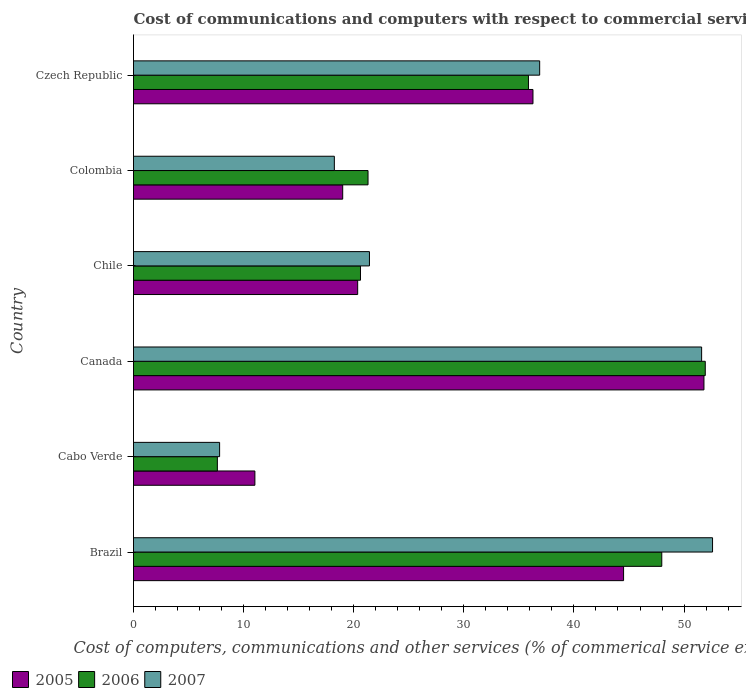Are the number of bars per tick equal to the number of legend labels?
Provide a short and direct response. Yes. Are the number of bars on each tick of the Y-axis equal?
Provide a short and direct response. Yes. How many bars are there on the 6th tick from the top?
Provide a short and direct response. 3. How many bars are there on the 5th tick from the bottom?
Keep it short and to the point. 3. What is the label of the 3rd group of bars from the top?
Offer a very short reply. Chile. In how many cases, is the number of bars for a given country not equal to the number of legend labels?
Offer a terse response. 0. What is the cost of communications and computers in 2005 in Colombia?
Your response must be concise. 19. Across all countries, what is the maximum cost of communications and computers in 2005?
Provide a short and direct response. 51.81. Across all countries, what is the minimum cost of communications and computers in 2005?
Provide a short and direct response. 11.02. In which country was the cost of communications and computers in 2005 minimum?
Your answer should be compact. Cabo Verde. What is the total cost of communications and computers in 2007 in the graph?
Provide a short and direct response. 188.56. What is the difference between the cost of communications and computers in 2006 in Canada and that in Chile?
Your answer should be compact. 31.31. What is the difference between the cost of communications and computers in 2006 in Canada and the cost of communications and computers in 2007 in Czech Republic?
Your response must be concise. 15.04. What is the average cost of communications and computers in 2006 per country?
Offer a terse response. 30.88. What is the difference between the cost of communications and computers in 2005 and cost of communications and computers in 2007 in Canada?
Offer a very short reply. 0.21. What is the ratio of the cost of communications and computers in 2005 in Brazil to that in Chile?
Your response must be concise. 2.19. Is the difference between the cost of communications and computers in 2005 in Canada and Colombia greater than the difference between the cost of communications and computers in 2007 in Canada and Colombia?
Offer a terse response. No. What is the difference between the highest and the second highest cost of communications and computers in 2007?
Give a very brief answer. 0.99. What is the difference between the highest and the lowest cost of communications and computers in 2006?
Offer a very short reply. 44.31. In how many countries, is the cost of communications and computers in 2005 greater than the average cost of communications and computers in 2005 taken over all countries?
Ensure brevity in your answer.  3. Is it the case that in every country, the sum of the cost of communications and computers in 2007 and cost of communications and computers in 2005 is greater than the cost of communications and computers in 2006?
Provide a short and direct response. Yes. How many bars are there?
Give a very brief answer. 18. How many countries are there in the graph?
Your response must be concise. 6. Are the values on the major ticks of X-axis written in scientific E-notation?
Ensure brevity in your answer.  No. Does the graph contain any zero values?
Give a very brief answer. No. Does the graph contain grids?
Provide a short and direct response. No. What is the title of the graph?
Your response must be concise. Cost of communications and computers with respect to commercial service exports. Does "1975" appear as one of the legend labels in the graph?
Provide a short and direct response. No. What is the label or title of the X-axis?
Give a very brief answer. Cost of computers, communications and other services (% of commerical service exports). What is the Cost of computers, communications and other services (% of commerical service exports) in 2005 in Brazil?
Ensure brevity in your answer.  44.51. What is the Cost of computers, communications and other services (% of commerical service exports) of 2006 in Brazil?
Keep it short and to the point. 47.98. What is the Cost of computers, communications and other services (% of commerical service exports) in 2007 in Brazil?
Your response must be concise. 52.59. What is the Cost of computers, communications and other services (% of commerical service exports) of 2005 in Cabo Verde?
Ensure brevity in your answer.  11.02. What is the Cost of computers, communications and other services (% of commerical service exports) of 2006 in Cabo Verde?
Provide a succinct answer. 7.62. What is the Cost of computers, communications and other services (% of commerical service exports) of 2007 in Cabo Verde?
Offer a very short reply. 7.82. What is the Cost of computers, communications and other services (% of commerical service exports) in 2005 in Canada?
Provide a short and direct response. 51.81. What is the Cost of computers, communications and other services (% of commerical service exports) of 2006 in Canada?
Your answer should be compact. 51.93. What is the Cost of computers, communications and other services (% of commerical service exports) in 2007 in Canada?
Give a very brief answer. 51.6. What is the Cost of computers, communications and other services (% of commerical service exports) of 2005 in Chile?
Make the answer very short. 20.36. What is the Cost of computers, communications and other services (% of commerical service exports) of 2006 in Chile?
Your response must be concise. 20.61. What is the Cost of computers, communications and other services (% of commerical service exports) of 2007 in Chile?
Your response must be concise. 21.43. What is the Cost of computers, communications and other services (% of commerical service exports) of 2005 in Colombia?
Your answer should be compact. 19. What is the Cost of computers, communications and other services (% of commerical service exports) in 2006 in Colombia?
Offer a terse response. 21.3. What is the Cost of computers, communications and other services (% of commerical service exports) in 2007 in Colombia?
Offer a very short reply. 18.24. What is the Cost of computers, communications and other services (% of commerical service exports) in 2005 in Czech Republic?
Keep it short and to the point. 36.28. What is the Cost of computers, communications and other services (% of commerical service exports) in 2006 in Czech Republic?
Provide a succinct answer. 35.87. What is the Cost of computers, communications and other services (% of commerical service exports) in 2007 in Czech Republic?
Offer a very short reply. 36.89. Across all countries, what is the maximum Cost of computers, communications and other services (% of commerical service exports) in 2005?
Give a very brief answer. 51.81. Across all countries, what is the maximum Cost of computers, communications and other services (% of commerical service exports) of 2006?
Offer a terse response. 51.93. Across all countries, what is the maximum Cost of computers, communications and other services (% of commerical service exports) of 2007?
Give a very brief answer. 52.59. Across all countries, what is the minimum Cost of computers, communications and other services (% of commerical service exports) in 2005?
Provide a short and direct response. 11.02. Across all countries, what is the minimum Cost of computers, communications and other services (% of commerical service exports) in 2006?
Ensure brevity in your answer.  7.62. Across all countries, what is the minimum Cost of computers, communications and other services (% of commerical service exports) in 2007?
Your answer should be compact. 7.82. What is the total Cost of computers, communications and other services (% of commerical service exports) of 2005 in the graph?
Your answer should be compact. 182.97. What is the total Cost of computers, communications and other services (% of commerical service exports) in 2006 in the graph?
Your answer should be very brief. 185.3. What is the total Cost of computers, communications and other services (% of commerical service exports) in 2007 in the graph?
Offer a terse response. 188.56. What is the difference between the Cost of computers, communications and other services (% of commerical service exports) of 2005 in Brazil and that in Cabo Verde?
Your answer should be very brief. 33.48. What is the difference between the Cost of computers, communications and other services (% of commerical service exports) of 2006 in Brazil and that in Cabo Verde?
Your answer should be compact. 40.36. What is the difference between the Cost of computers, communications and other services (% of commerical service exports) in 2007 in Brazil and that in Cabo Verde?
Keep it short and to the point. 44.77. What is the difference between the Cost of computers, communications and other services (% of commerical service exports) in 2005 in Brazil and that in Canada?
Your answer should be compact. -7.3. What is the difference between the Cost of computers, communications and other services (% of commerical service exports) in 2006 in Brazil and that in Canada?
Ensure brevity in your answer.  -3.95. What is the difference between the Cost of computers, communications and other services (% of commerical service exports) of 2005 in Brazil and that in Chile?
Your answer should be very brief. 24.15. What is the difference between the Cost of computers, communications and other services (% of commerical service exports) in 2006 in Brazil and that in Chile?
Your response must be concise. 27.36. What is the difference between the Cost of computers, communications and other services (% of commerical service exports) of 2007 in Brazil and that in Chile?
Provide a short and direct response. 31.16. What is the difference between the Cost of computers, communications and other services (% of commerical service exports) of 2005 in Brazil and that in Colombia?
Your answer should be compact. 25.51. What is the difference between the Cost of computers, communications and other services (% of commerical service exports) in 2006 in Brazil and that in Colombia?
Provide a succinct answer. 26.68. What is the difference between the Cost of computers, communications and other services (% of commerical service exports) in 2007 in Brazil and that in Colombia?
Give a very brief answer. 34.35. What is the difference between the Cost of computers, communications and other services (% of commerical service exports) in 2005 in Brazil and that in Czech Republic?
Your response must be concise. 8.23. What is the difference between the Cost of computers, communications and other services (% of commerical service exports) in 2006 in Brazil and that in Czech Republic?
Ensure brevity in your answer.  12.11. What is the difference between the Cost of computers, communications and other services (% of commerical service exports) in 2007 in Brazil and that in Czech Republic?
Provide a succinct answer. 15.7. What is the difference between the Cost of computers, communications and other services (% of commerical service exports) in 2005 in Cabo Verde and that in Canada?
Your answer should be very brief. -40.78. What is the difference between the Cost of computers, communications and other services (% of commerical service exports) in 2006 in Cabo Verde and that in Canada?
Provide a succinct answer. -44.31. What is the difference between the Cost of computers, communications and other services (% of commerical service exports) of 2007 in Cabo Verde and that in Canada?
Offer a terse response. -43.78. What is the difference between the Cost of computers, communications and other services (% of commerical service exports) of 2005 in Cabo Verde and that in Chile?
Your answer should be compact. -9.33. What is the difference between the Cost of computers, communications and other services (% of commerical service exports) of 2006 in Cabo Verde and that in Chile?
Ensure brevity in your answer.  -13. What is the difference between the Cost of computers, communications and other services (% of commerical service exports) of 2007 in Cabo Verde and that in Chile?
Your response must be concise. -13.61. What is the difference between the Cost of computers, communications and other services (% of commerical service exports) in 2005 in Cabo Verde and that in Colombia?
Ensure brevity in your answer.  -7.97. What is the difference between the Cost of computers, communications and other services (% of commerical service exports) in 2006 in Cabo Verde and that in Colombia?
Your response must be concise. -13.68. What is the difference between the Cost of computers, communications and other services (% of commerical service exports) of 2007 in Cabo Verde and that in Colombia?
Provide a short and direct response. -10.42. What is the difference between the Cost of computers, communications and other services (% of commerical service exports) in 2005 in Cabo Verde and that in Czech Republic?
Provide a short and direct response. -25.25. What is the difference between the Cost of computers, communications and other services (% of commerical service exports) of 2006 in Cabo Verde and that in Czech Republic?
Offer a terse response. -28.25. What is the difference between the Cost of computers, communications and other services (% of commerical service exports) in 2007 in Cabo Verde and that in Czech Republic?
Offer a terse response. -29.07. What is the difference between the Cost of computers, communications and other services (% of commerical service exports) of 2005 in Canada and that in Chile?
Your answer should be very brief. 31.45. What is the difference between the Cost of computers, communications and other services (% of commerical service exports) of 2006 in Canada and that in Chile?
Offer a terse response. 31.31. What is the difference between the Cost of computers, communications and other services (% of commerical service exports) of 2007 in Canada and that in Chile?
Give a very brief answer. 30.17. What is the difference between the Cost of computers, communications and other services (% of commerical service exports) in 2005 in Canada and that in Colombia?
Your answer should be compact. 32.81. What is the difference between the Cost of computers, communications and other services (% of commerical service exports) of 2006 in Canada and that in Colombia?
Offer a very short reply. 30.63. What is the difference between the Cost of computers, communications and other services (% of commerical service exports) of 2007 in Canada and that in Colombia?
Ensure brevity in your answer.  33.36. What is the difference between the Cost of computers, communications and other services (% of commerical service exports) of 2005 in Canada and that in Czech Republic?
Make the answer very short. 15.53. What is the difference between the Cost of computers, communications and other services (% of commerical service exports) of 2006 in Canada and that in Czech Republic?
Provide a short and direct response. 16.06. What is the difference between the Cost of computers, communications and other services (% of commerical service exports) of 2007 in Canada and that in Czech Republic?
Your answer should be compact. 14.71. What is the difference between the Cost of computers, communications and other services (% of commerical service exports) in 2005 in Chile and that in Colombia?
Your answer should be very brief. 1.36. What is the difference between the Cost of computers, communications and other services (% of commerical service exports) in 2006 in Chile and that in Colombia?
Ensure brevity in your answer.  -0.69. What is the difference between the Cost of computers, communications and other services (% of commerical service exports) of 2007 in Chile and that in Colombia?
Make the answer very short. 3.19. What is the difference between the Cost of computers, communications and other services (% of commerical service exports) of 2005 in Chile and that in Czech Republic?
Provide a succinct answer. -15.92. What is the difference between the Cost of computers, communications and other services (% of commerical service exports) of 2006 in Chile and that in Czech Republic?
Give a very brief answer. -15.25. What is the difference between the Cost of computers, communications and other services (% of commerical service exports) in 2007 in Chile and that in Czech Republic?
Offer a very short reply. -15.46. What is the difference between the Cost of computers, communications and other services (% of commerical service exports) in 2005 in Colombia and that in Czech Republic?
Ensure brevity in your answer.  -17.28. What is the difference between the Cost of computers, communications and other services (% of commerical service exports) in 2006 in Colombia and that in Czech Republic?
Your response must be concise. -14.57. What is the difference between the Cost of computers, communications and other services (% of commerical service exports) in 2007 in Colombia and that in Czech Republic?
Offer a very short reply. -18.65. What is the difference between the Cost of computers, communications and other services (% of commerical service exports) of 2005 in Brazil and the Cost of computers, communications and other services (% of commerical service exports) of 2006 in Cabo Verde?
Your answer should be compact. 36.89. What is the difference between the Cost of computers, communications and other services (% of commerical service exports) of 2005 in Brazil and the Cost of computers, communications and other services (% of commerical service exports) of 2007 in Cabo Verde?
Your answer should be very brief. 36.69. What is the difference between the Cost of computers, communications and other services (% of commerical service exports) of 2006 in Brazil and the Cost of computers, communications and other services (% of commerical service exports) of 2007 in Cabo Verde?
Provide a short and direct response. 40.16. What is the difference between the Cost of computers, communications and other services (% of commerical service exports) in 2005 in Brazil and the Cost of computers, communications and other services (% of commerical service exports) in 2006 in Canada?
Keep it short and to the point. -7.42. What is the difference between the Cost of computers, communications and other services (% of commerical service exports) in 2005 in Brazil and the Cost of computers, communications and other services (% of commerical service exports) in 2007 in Canada?
Your answer should be compact. -7.09. What is the difference between the Cost of computers, communications and other services (% of commerical service exports) of 2006 in Brazil and the Cost of computers, communications and other services (% of commerical service exports) of 2007 in Canada?
Keep it short and to the point. -3.62. What is the difference between the Cost of computers, communications and other services (% of commerical service exports) in 2005 in Brazil and the Cost of computers, communications and other services (% of commerical service exports) in 2006 in Chile?
Give a very brief answer. 23.89. What is the difference between the Cost of computers, communications and other services (% of commerical service exports) of 2005 in Brazil and the Cost of computers, communications and other services (% of commerical service exports) of 2007 in Chile?
Provide a short and direct response. 23.08. What is the difference between the Cost of computers, communications and other services (% of commerical service exports) in 2006 in Brazil and the Cost of computers, communications and other services (% of commerical service exports) in 2007 in Chile?
Your answer should be very brief. 26.55. What is the difference between the Cost of computers, communications and other services (% of commerical service exports) of 2005 in Brazil and the Cost of computers, communications and other services (% of commerical service exports) of 2006 in Colombia?
Provide a short and direct response. 23.21. What is the difference between the Cost of computers, communications and other services (% of commerical service exports) of 2005 in Brazil and the Cost of computers, communications and other services (% of commerical service exports) of 2007 in Colombia?
Provide a short and direct response. 26.27. What is the difference between the Cost of computers, communications and other services (% of commerical service exports) of 2006 in Brazil and the Cost of computers, communications and other services (% of commerical service exports) of 2007 in Colombia?
Offer a very short reply. 29.74. What is the difference between the Cost of computers, communications and other services (% of commerical service exports) of 2005 in Brazil and the Cost of computers, communications and other services (% of commerical service exports) of 2006 in Czech Republic?
Your answer should be very brief. 8.64. What is the difference between the Cost of computers, communications and other services (% of commerical service exports) of 2005 in Brazil and the Cost of computers, communications and other services (% of commerical service exports) of 2007 in Czech Republic?
Keep it short and to the point. 7.62. What is the difference between the Cost of computers, communications and other services (% of commerical service exports) of 2006 in Brazil and the Cost of computers, communications and other services (% of commerical service exports) of 2007 in Czech Republic?
Provide a succinct answer. 11.09. What is the difference between the Cost of computers, communications and other services (% of commerical service exports) in 2005 in Cabo Verde and the Cost of computers, communications and other services (% of commerical service exports) in 2006 in Canada?
Your response must be concise. -40.9. What is the difference between the Cost of computers, communications and other services (% of commerical service exports) in 2005 in Cabo Verde and the Cost of computers, communications and other services (% of commerical service exports) in 2007 in Canada?
Make the answer very short. -40.57. What is the difference between the Cost of computers, communications and other services (% of commerical service exports) in 2006 in Cabo Verde and the Cost of computers, communications and other services (% of commerical service exports) in 2007 in Canada?
Your answer should be very brief. -43.98. What is the difference between the Cost of computers, communications and other services (% of commerical service exports) of 2005 in Cabo Verde and the Cost of computers, communications and other services (% of commerical service exports) of 2006 in Chile?
Give a very brief answer. -9.59. What is the difference between the Cost of computers, communications and other services (% of commerical service exports) of 2005 in Cabo Verde and the Cost of computers, communications and other services (% of commerical service exports) of 2007 in Chile?
Keep it short and to the point. -10.4. What is the difference between the Cost of computers, communications and other services (% of commerical service exports) in 2006 in Cabo Verde and the Cost of computers, communications and other services (% of commerical service exports) in 2007 in Chile?
Make the answer very short. -13.81. What is the difference between the Cost of computers, communications and other services (% of commerical service exports) in 2005 in Cabo Verde and the Cost of computers, communications and other services (% of commerical service exports) in 2006 in Colombia?
Your response must be concise. -10.27. What is the difference between the Cost of computers, communications and other services (% of commerical service exports) of 2005 in Cabo Verde and the Cost of computers, communications and other services (% of commerical service exports) of 2007 in Colombia?
Your answer should be very brief. -7.22. What is the difference between the Cost of computers, communications and other services (% of commerical service exports) of 2006 in Cabo Verde and the Cost of computers, communications and other services (% of commerical service exports) of 2007 in Colombia?
Provide a succinct answer. -10.62. What is the difference between the Cost of computers, communications and other services (% of commerical service exports) in 2005 in Cabo Verde and the Cost of computers, communications and other services (% of commerical service exports) in 2006 in Czech Republic?
Give a very brief answer. -24.84. What is the difference between the Cost of computers, communications and other services (% of commerical service exports) in 2005 in Cabo Verde and the Cost of computers, communications and other services (% of commerical service exports) in 2007 in Czech Republic?
Keep it short and to the point. -25.86. What is the difference between the Cost of computers, communications and other services (% of commerical service exports) of 2006 in Cabo Verde and the Cost of computers, communications and other services (% of commerical service exports) of 2007 in Czech Republic?
Make the answer very short. -29.27. What is the difference between the Cost of computers, communications and other services (% of commerical service exports) of 2005 in Canada and the Cost of computers, communications and other services (% of commerical service exports) of 2006 in Chile?
Offer a very short reply. 31.19. What is the difference between the Cost of computers, communications and other services (% of commerical service exports) in 2005 in Canada and the Cost of computers, communications and other services (% of commerical service exports) in 2007 in Chile?
Make the answer very short. 30.38. What is the difference between the Cost of computers, communications and other services (% of commerical service exports) in 2006 in Canada and the Cost of computers, communications and other services (% of commerical service exports) in 2007 in Chile?
Ensure brevity in your answer.  30.5. What is the difference between the Cost of computers, communications and other services (% of commerical service exports) of 2005 in Canada and the Cost of computers, communications and other services (% of commerical service exports) of 2006 in Colombia?
Make the answer very short. 30.51. What is the difference between the Cost of computers, communications and other services (% of commerical service exports) in 2005 in Canada and the Cost of computers, communications and other services (% of commerical service exports) in 2007 in Colombia?
Offer a very short reply. 33.57. What is the difference between the Cost of computers, communications and other services (% of commerical service exports) in 2006 in Canada and the Cost of computers, communications and other services (% of commerical service exports) in 2007 in Colombia?
Offer a terse response. 33.69. What is the difference between the Cost of computers, communications and other services (% of commerical service exports) of 2005 in Canada and the Cost of computers, communications and other services (% of commerical service exports) of 2006 in Czech Republic?
Your response must be concise. 15.94. What is the difference between the Cost of computers, communications and other services (% of commerical service exports) in 2005 in Canada and the Cost of computers, communications and other services (% of commerical service exports) in 2007 in Czech Republic?
Offer a very short reply. 14.92. What is the difference between the Cost of computers, communications and other services (% of commerical service exports) in 2006 in Canada and the Cost of computers, communications and other services (% of commerical service exports) in 2007 in Czech Republic?
Your response must be concise. 15.04. What is the difference between the Cost of computers, communications and other services (% of commerical service exports) in 2005 in Chile and the Cost of computers, communications and other services (% of commerical service exports) in 2006 in Colombia?
Provide a succinct answer. -0.94. What is the difference between the Cost of computers, communications and other services (% of commerical service exports) of 2005 in Chile and the Cost of computers, communications and other services (% of commerical service exports) of 2007 in Colombia?
Offer a very short reply. 2.12. What is the difference between the Cost of computers, communications and other services (% of commerical service exports) in 2006 in Chile and the Cost of computers, communications and other services (% of commerical service exports) in 2007 in Colombia?
Provide a succinct answer. 2.37. What is the difference between the Cost of computers, communications and other services (% of commerical service exports) in 2005 in Chile and the Cost of computers, communications and other services (% of commerical service exports) in 2006 in Czech Republic?
Provide a succinct answer. -15.51. What is the difference between the Cost of computers, communications and other services (% of commerical service exports) of 2005 in Chile and the Cost of computers, communications and other services (% of commerical service exports) of 2007 in Czech Republic?
Your response must be concise. -16.53. What is the difference between the Cost of computers, communications and other services (% of commerical service exports) of 2006 in Chile and the Cost of computers, communications and other services (% of commerical service exports) of 2007 in Czech Republic?
Offer a terse response. -16.27. What is the difference between the Cost of computers, communications and other services (% of commerical service exports) in 2005 in Colombia and the Cost of computers, communications and other services (% of commerical service exports) in 2006 in Czech Republic?
Ensure brevity in your answer.  -16.87. What is the difference between the Cost of computers, communications and other services (% of commerical service exports) in 2005 in Colombia and the Cost of computers, communications and other services (% of commerical service exports) in 2007 in Czech Republic?
Offer a terse response. -17.89. What is the difference between the Cost of computers, communications and other services (% of commerical service exports) in 2006 in Colombia and the Cost of computers, communications and other services (% of commerical service exports) in 2007 in Czech Republic?
Your response must be concise. -15.59. What is the average Cost of computers, communications and other services (% of commerical service exports) of 2005 per country?
Your answer should be compact. 30.5. What is the average Cost of computers, communications and other services (% of commerical service exports) of 2006 per country?
Give a very brief answer. 30.88. What is the average Cost of computers, communications and other services (% of commerical service exports) of 2007 per country?
Offer a terse response. 31.43. What is the difference between the Cost of computers, communications and other services (% of commerical service exports) of 2005 and Cost of computers, communications and other services (% of commerical service exports) of 2006 in Brazil?
Your answer should be compact. -3.47. What is the difference between the Cost of computers, communications and other services (% of commerical service exports) of 2005 and Cost of computers, communications and other services (% of commerical service exports) of 2007 in Brazil?
Offer a very short reply. -8.08. What is the difference between the Cost of computers, communications and other services (% of commerical service exports) of 2006 and Cost of computers, communications and other services (% of commerical service exports) of 2007 in Brazil?
Provide a short and direct response. -4.61. What is the difference between the Cost of computers, communications and other services (% of commerical service exports) in 2005 and Cost of computers, communications and other services (% of commerical service exports) in 2006 in Cabo Verde?
Your answer should be compact. 3.41. What is the difference between the Cost of computers, communications and other services (% of commerical service exports) of 2005 and Cost of computers, communications and other services (% of commerical service exports) of 2007 in Cabo Verde?
Offer a very short reply. 3.21. What is the difference between the Cost of computers, communications and other services (% of commerical service exports) in 2006 and Cost of computers, communications and other services (% of commerical service exports) in 2007 in Cabo Verde?
Your response must be concise. -0.2. What is the difference between the Cost of computers, communications and other services (% of commerical service exports) in 2005 and Cost of computers, communications and other services (% of commerical service exports) in 2006 in Canada?
Provide a short and direct response. -0.12. What is the difference between the Cost of computers, communications and other services (% of commerical service exports) of 2005 and Cost of computers, communications and other services (% of commerical service exports) of 2007 in Canada?
Provide a short and direct response. 0.21. What is the difference between the Cost of computers, communications and other services (% of commerical service exports) of 2006 and Cost of computers, communications and other services (% of commerical service exports) of 2007 in Canada?
Keep it short and to the point. 0.33. What is the difference between the Cost of computers, communications and other services (% of commerical service exports) of 2005 and Cost of computers, communications and other services (% of commerical service exports) of 2006 in Chile?
Offer a very short reply. -0.26. What is the difference between the Cost of computers, communications and other services (% of commerical service exports) in 2005 and Cost of computers, communications and other services (% of commerical service exports) in 2007 in Chile?
Provide a short and direct response. -1.07. What is the difference between the Cost of computers, communications and other services (% of commerical service exports) of 2006 and Cost of computers, communications and other services (% of commerical service exports) of 2007 in Chile?
Provide a short and direct response. -0.81. What is the difference between the Cost of computers, communications and other services (% of commerical service exports) in 2005 and Cost of computers, communications and other services (% of commerical service exports) in 2006 in Colombia?
Your answer should be compact. -2.3. What is the difference between the Cost of computers, communications and other services (% of commerical service exports) in 2005 and Cost of computers, communications and other services (% of commerical service exports) in 2007 in Colombia?
Offer a very short reply. 0.76. What is the difference between the Cost of computers, communications and other services (% of commerical service exports) of 2006 and Cost of computers, communications and other services (% of commerical service exports) of 2007 in Colombia?
Provide a short and direct response. 3.06. What is the difference between the Cost of computers, communications and other services (% of commerical service exports) in 2005 and Cost of computers, communications and other services (% of commerical service exports) in 2006 in Czech Republic?
Ensure brevity in your answer.  0.41. What is the difference between the Cost of computers, communications and other services (% of commerical service exports) of 2005 and Cost of computers, communications and other services (% of commerical service exports) of 2007 in Czech Republic?
Your response must be concise. -0.61. What is the difference between the Cost of computers, communications and other services (% of commerical service exports) in 2006 and Cost of computers, communications and other services (% of commerical service exports) in 2007 in Czech Republic?
Offer a terse response. -1.02. What is the ratio of the Cost of computers, communications and other services (% of commerical service exports) in 2005 in Brazil to that in Cabo Verde?
Ensure brevity in your answer.  4.04. What is the ratio of the Cost of computers, communications and other services (% of commerical service exports) in 2006 in Brazil to that in Cabo Verde?
Your response must be concise. 6.3. What is the ratio of the Cost of computers, communications and other services (% of commerical service exports) of 2007 in Brazil to that in Cabo Verde?
Make the answer very short. 6.73. What is the ratio of the Cost of computers, communications and other services (% of commerical service exports) of 2005 in Brazil to that in Canada?
Your response must be concise. 0.86. What is the ratio of the Cost of computers, communications and other services (% of commerical service exports) in 2006 in Brazil to that in Canada?
Your response must be concise. 0.92. What is the ratio of the Cost of computers, communications and other services (% of commerical service exports) of 2007 in Brazil to that in Canada?
Offer a terse response. 1.02. What is the ratio of the Cost of computers, communications and other services (% of commerical service exports) of 2005 in Brazil to that in Chile?
Offer a terse response. 2.19. What is the ratio of the Cost of computers, communications and other services (% of commerical service exports) of 2006 in Brazil to that in Chile?
Make the answer very short. 2.33. What is the ratio of the Cost of computers, communications and other services (% of commerical service exports) of 2007 in Brazil to that in Chile?
Ensure brevity in your answer.  2.45. What is the ratio of the Cost of computers, communications and other services (% of commerical service exports) of 2005 in Brazil to that in Colombia?
Keep it short and to the point. 2.34. What is the ratio of the Cost of computers, communications and other services (% of commerical service exports) in 2006 in Brazil to that in Colombia?
Offer a very short reply. 2.25. What is the ratio of the Cost of computers, communications and other services (% of commerical service exports) in 2007 in Brazil to that in Colombia?
Your answer should be very brief. 2.88. What is the ratio of the Cost of computers, communications and other services (% of commerical service exports) in 2005 in Brazil to that in Czech Republic?
Provide a succinct answer. 1.23. What is the ratio of the Cost of computers, communications and other services (% of commerical service exports) in 2006 in Brazil to that in Czech Republic?
Your answer should be very brief. 1.34. What is the ratio of the Cost of computers, communications and other services (% of commerical service exports) of 2007 in Brazil to that in Czech Republic?
Ensure brevity in your answer.  1.43. What is the ratio of the Cost of computers, communications and other services (% of commerical service exports) of 2005 in Cabo Verde to that in Canada?
Your response must be concise. 0.21. What is the ratio of the Cost of computers, communications and other services (% of commerical service exports) of 2006 in Cabo Verde to that in Canada?
Provide a succinct answer. 0.15. What is the ratio of the Cost of computers, communications and other services (% of commerical service exports) in 2007 in Cabo Verde to that in Canada?
Provide a short and direct response. 0.15. What is the ratio of the Cost of computers, communications and other services (% of commerical service exports) in 2005 in Cabo Verde to that in Chile?
Provide a short and direct response. 0.54. What is the ratio of the Cost of computers, communications and other services (% of commerical service exports) of 2006 in Cabo Verde to that in Chile?
Give a very brief answer. 0.37. What is the ratio of the Cost of computers, communications and other services (% of commerical service exports) in 2007 in Cabo Verde to that in Chile?
Give a very brief answer. 0.36. What is the ratio of the Cost of computers, communications and other services (% of commerical service exports) in 2005 in Cabo Verde to that in Colombia?
Keep it short and to the point. 0.58. What is the ratio of the Cost of computers, communications and other services (% of commerical service exports) in 2006 in Cabo Verde to that in Colombia?
Make the answer very short. 0.36. What is the ratio of the Cost of computers, communications and other services (% of commerical service exports) of 2007 in Cabo Verde to that in Colombia?
Your answer should be compact. 0.43. What is the ratio of the Cost of computers, communications and other services (% of commerical service exports) of 2005 in Cabo Verde to that in Czech Republic?
Your response must be concise. 0.3. What is the ratio of the Cost of computers, communications and other services (% of commerical service exports) in 2006 in Cabo Verde to that in Czech Republic?
Make the answer very short. 0.21. What is the ratio of the Cost of computers, communications and other services (% of commerical service exports) in 2007 in Cabo Verde to that in Czech Republic?
Keep it short and to the point. 0.21. What is the ratio of the Cost of computers, communications and other services (% of commerical service exports) in 2005 in Canada to that in Chile?
Your answer should be compact. 2.54. What is the ratio of the Cost of computers, communications and other services (% of commerical service exports) of 2006 in Canada to that in Chile?
Make the answer very short. 2.52. What is the ratio of the Cost of computers, communications and other services (% of commerical service exports) of 2007 in Canada to that in Chile?
Provide a short and direct response. 2.41. What is the ratio of the Cost of computers, communications and other services (% of commerical service exports) of 2005 in Canada to that in Colombia?
Your answer should be compact. 2.73. What is the ratio of the Cost of computers, communications and other services (% of commerical service exports) of 2006 in Canada to that in Colombia?
Offer a terse response. 2.44. What is the ratio of the Cost of computers, communications and other services (% of commerical service exports) in 2007 in Canada to that in Colombia?
Keep it short and to the point. 2.83. What is the ratio of the Cost of computers, communications and other services (% of commerical service exports) in 2005 in Canada to that in Czech Republic?
Provide a succinct answer. 1.43. What is the ratio of the Cost of computers, communications and other services (% of commerical service exports) of 2006 in Canada to that in Czech Republic?
Your answer should be very brief. 1.45. What is the ratio of the Cost of computers, communications and other services (% of commerical service exports) in 2007 in Canada to that in Czech Republic?
Provide a short and direct response. 1.4. What is the ratio of the Cost of computers, communications and other services (% of commerical service exports) of 2005 in Chile to that in Colombia?
Your answer should be compact. 1.07. What is the ratio of the Cost of computers, communications and other services (% of commerical service exports) in 2006 in Chile to that in Colombia?
Provide a succinct answer. 0.97. What is the ratio of the Cost of computers, communications and other services (% of commerical service exports) in 2007 in Chile to that in Colombia?
Make the answer very short. 1.17. What is the ratio of the Cost of computers, communications and other services (% of commerical service exports) in 2005 in Chile to that in Czech Republic?
Offer a terse response. 0.56. What is the ratio of the Cost of computers, communications and other services (% of commerical service exports) in 2006 in Chile to that in Czech Republic?
Make the answer very short. 0.57. What is the ratio of the Cost of computers, communications and other services (% of commerical service exports) in 2007 in Chile to that in Czech Republic?
Ensure brevity in your answer.  0.58. What is the ratio of the Cost of computers, communications and other services (% of commerical service exports) of 2005 in Colombia to that in Czech Republic?
Provide a short and direct response. 0.52. What is the ratio of the Cost of computers, communications and other services (% of commerical service exports) in 2006 in Colombia to that in Czech Republic?
Make the answer very short. 0.59. What is the ratio of the Cost of computers, communications and other services (% of commerical service exports) of 2007 in Colombia to that in Czech Republic?
Make the answer very short. 0.49. What is the difference between the highest and the second highest Cost of computers, communications and other services (% of commerical service exports) of 2005?
Provide a succinct answer. 7.3. What is the difference between the highest and the second highest Cost of computers, communications and other services (% of commerical service exports) of 2006?
Your answer should be compact. 3.95. What is the difference between the highest and the lowest Cost of computers, communications and other services (% of commerical service exports) in 2005?
Make the answer very short. 40.78. What is the difference between the highest and the lowest Cost of computers, communications and other services (% of commerical service exports) of 2006?
Your answer should be compact. 44.31. What is the difference between the highest and the lowest Cost of computers, communications and other services (% of commerical service exports) in 2007?
Ensure brevity in your answer.  44.77. 